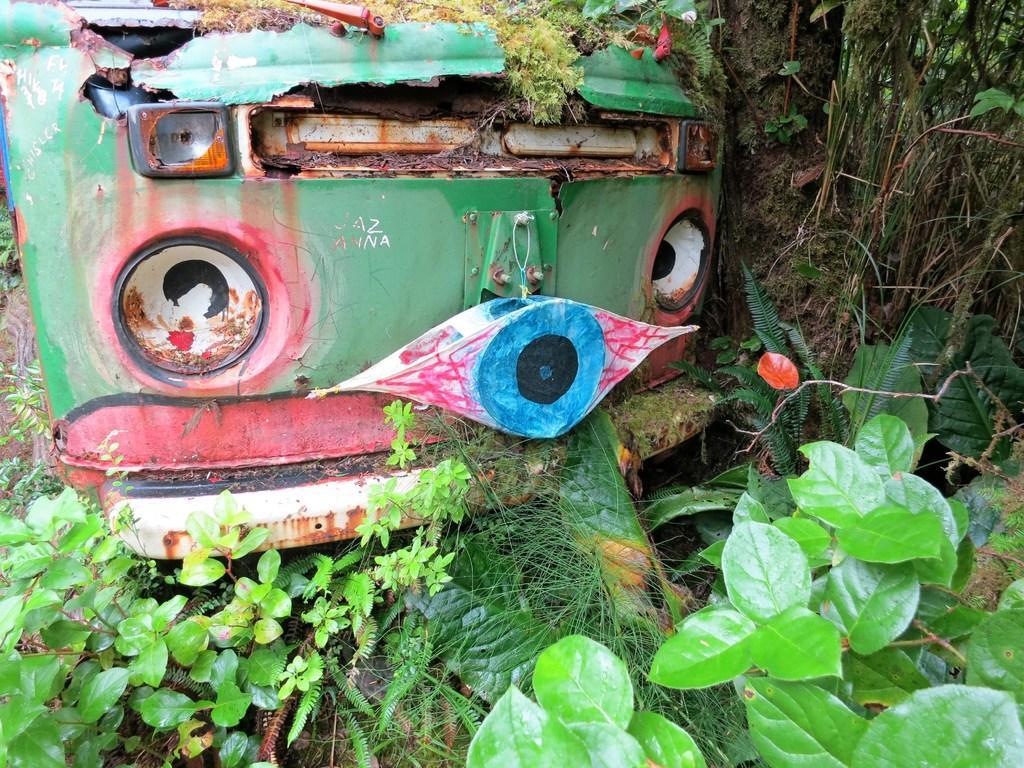How would you summarize this image in a sentence or two? In this image in the center there is one vehicle and on the right side there are some trees, at the bottom there are some plants and grass. 